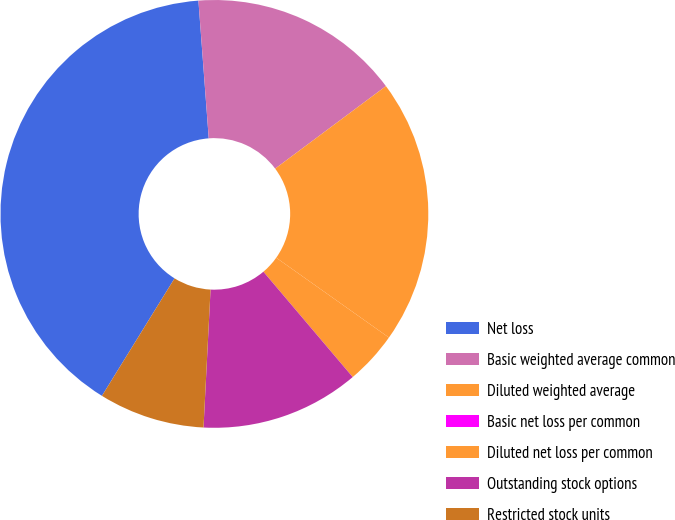Convert chart to OTSL. <chart><loc_0><loc_0><loc_500><loc_500><pie_chart><fcel>Net loss<fcel>Basic weighted average common<fcel>Diluted weighted average<fcel>Basic net loss per common<fcel>Diluted net loss per common<fcel>Outstanding stock options<fcel>Restricted stock units<nl><fcel>40.0%<fcel>16.0%<fcel>20.0%<fcel>0.0%<fcel>4.0%<fcel>12.0%<fcel>8.0%<nl></chart> 